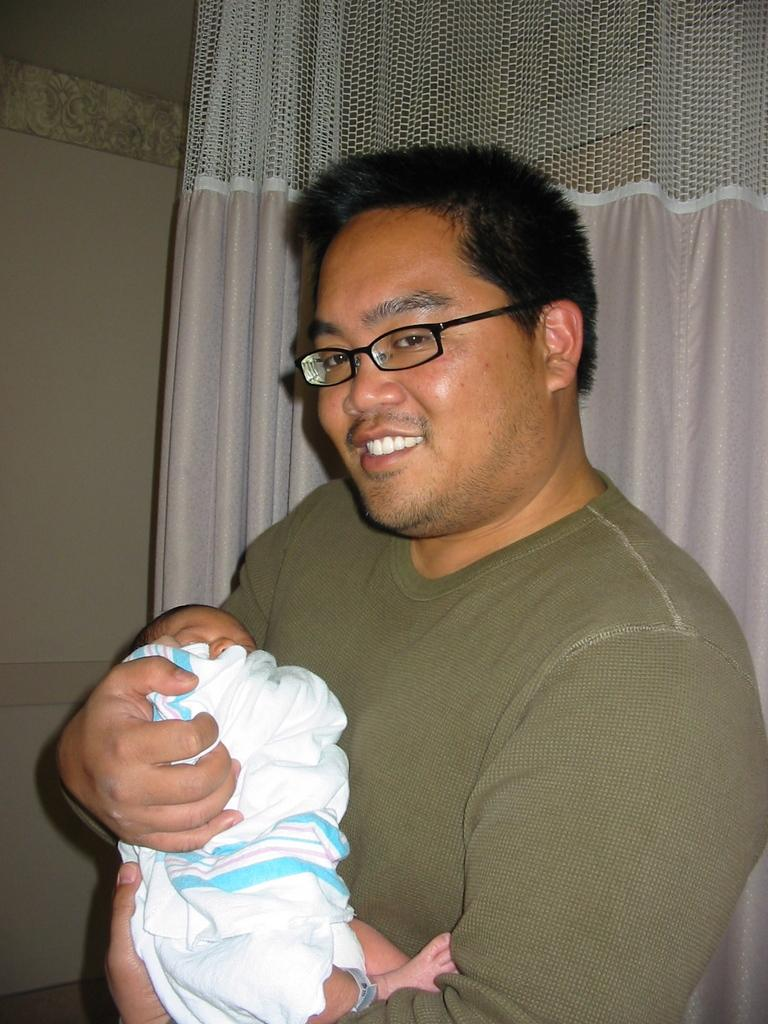What is the main subject of the image? There is a person in the image. What is the person doing in the image? The person is holding a baby. What is the facial expression of the person in the image? The person is smiling. What can be seen in the background of the image? There is a curtain and a wall in the background of the image. What type of carriage is visible in the image? There is no carriage present in the image. Can you describe the position of the zipper on the baby's clothing in the image? There is no zipper visible on the baby's clothing in the image. 